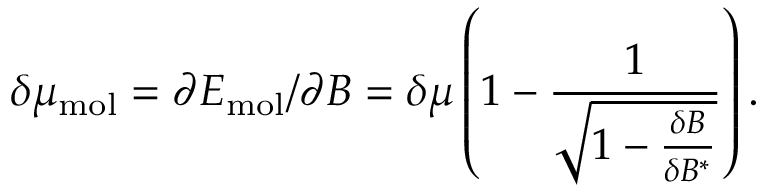<formula> <loc_0><loc_0><loc_500><loc_500>\delta \mu _ { m o l } = \partial E _ { m o l } / \partial B = \delta \mu \left ( 1 - \frac { 1 } { \sqrt { 1 - \frac { \delta B } { \delta B ^ { * } } } } \right ) .</formula> 